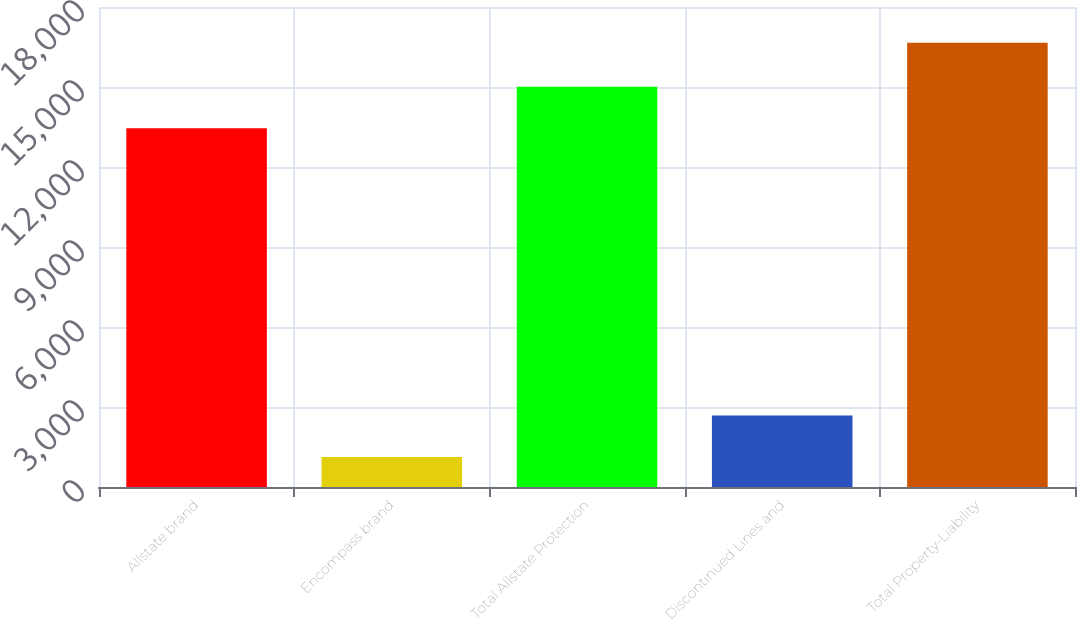Convert chart to OTSL. <chart><loc_0><loc_0><loc_500><loc_500><bar_chart><fcel>Allstate brand<fcel>Encompass brand<fcel>Total Allstate Protection<fcel>Discontinued Lines and<fcel>Total Property-Liability<nl><fcel>13456<fcel>1129<fcel>15009.1<fcel>2682.1<fcel>16660<nl></chart> 